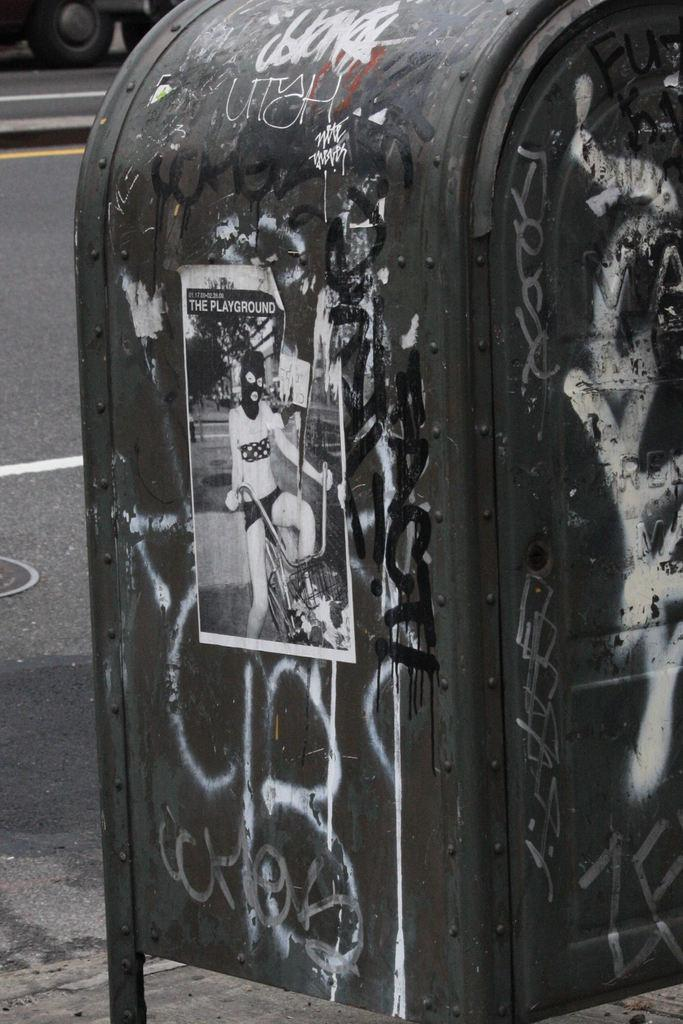What is the main subject in the image? There is a poster in the image. What can be seen on the poster? There are texts written on an object in the image. What is visible in the background of the image? There is a vehicle visible in the background of the image. Where is the vehicle located? The vehicle is on the road. What is the limit of the spy's reaction in the image? There is no mention of a spy or any reaction in the image; it features a poster with texts and a vehicle on the road. 